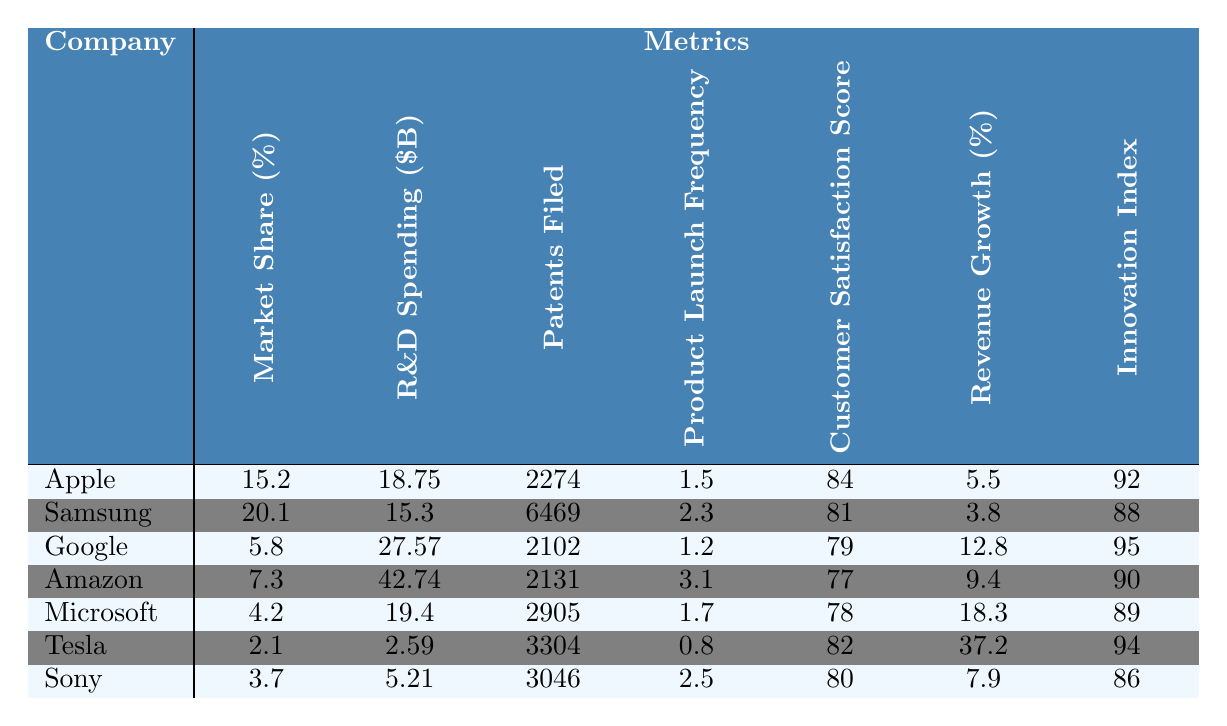What is the market share of Apple? The market share for Apple is listed directly in the table under the "Market Share (%)" column, which shows a value of 15.2.
Answer: 15.2 Which company has the highest number of patents filed? In the table, the "Patents Filed" column shows Samsung with 6469 patents, which is more than any other company listed.
Answer: Samsung What is the product launch frequency for Amazon? By looking at the "Product Launch Frequency" column, we can see that Amazon has a frequency of 3.1.
Answer: 3.1 Which company has the lowest revenue growth percentage? Examining the "Revenue Growth (%)" column, we see that Samsung has the lowest value at 3.8.
Answer: Samsung What is the average customer satisfaction score for the companies listed? The customer satisfaction scores are: 84 (Apple), 81 (Samsung), 79 (Google), 77 (Amazon), 78 (Microsoft), 82 (Tesla), and 80 (Sony). Adding these gives a total of 561. Dividing by 7 gives an average of 80.14.
Answer: 80.14 Is Tesla's R&D spending higher than Microsoft's? Tesla's R&D spending is $2.59B while Microsoft's is $19.4B; therefore, Tesla's spending is not higher.
Answer: No What is the difference in innovation index between Google and Sony? Google has an Innovation Index of 95, while Sony has an index of 86. Therefore, the difference is 95 - 86 = 9.
Answer: 9 Which company's revenue growth percentage exceeds 10%? Looking at the "Revenue Growth (%)" column, Google (12.8%) and Tesla (37.2%) both exceed 10%.
Answer: Google and Tesla If you combine the patents filed by Apple and Microsoft, how many patents do they have in total? From the table, Apple has filed 2274 patents and Microsoft has filed 2905 patents. Adding these gives 2274 + 2905 = 5179 patents total.
Answer: 5179 Which company has the highest R&D spending and how does it compare to the average R&D spending of all companies? Amazon has the highest R&D spending at $42.74B. The average R&D spending is (18.75 + 15.3 + 27.57 + 42.74 + 19.4 + 2.59 + 5.21) = 129.56 B; dividing by 7 gives approximately $18.51B. Compared to the average, Amazon's spending is significantly higher.
Answer: Amazon; significantly higher than average 